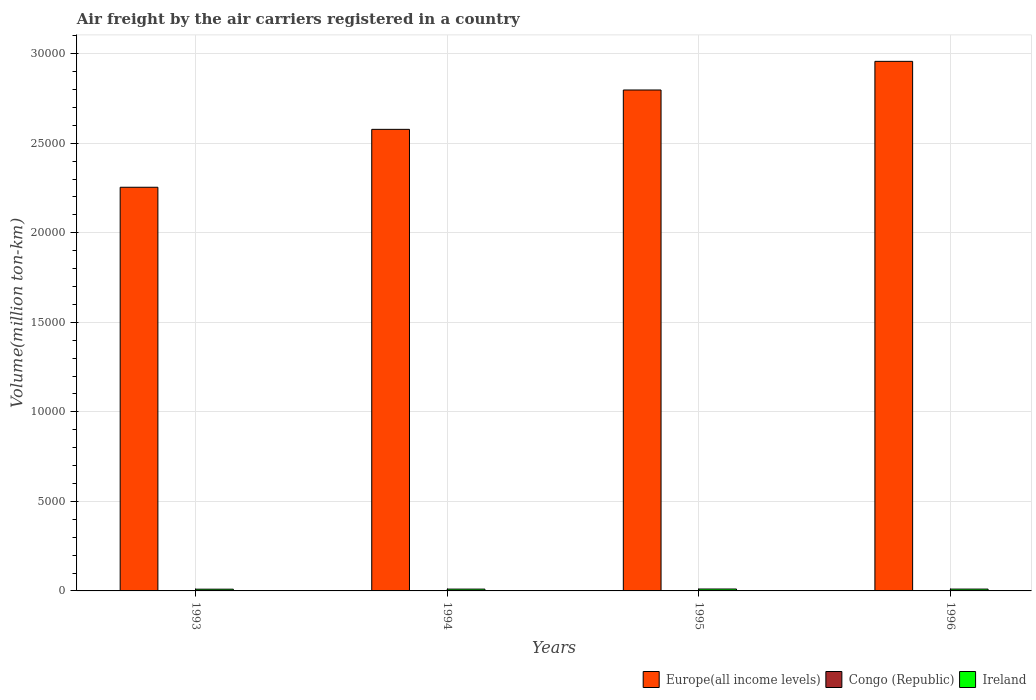How many different coloured bars are there?
Give a very brief answer. 3. Are the number of bars per tick equal to the number of legend labels?
Your answer should be compact. Yes. Are the number of bars on each tick of the X-axis equal?
Your answer should be very brief. Yes. How many bars are there on the 4th tick from the left?
Provide a succinct answer. 3. How many bars are there on the 4th tick from the right?
Your answer should be very brief. 3. Across all years, what is the maximum volume of the air carriers in Europe(all income levels)?
Give a very brief answer. 2.96e+04. Across all years, what is the minimum volume of the air carriers in Europe(all income levels)?
Your answer should be very brief. 2.25e+04. In which year was the volume of the air carriers in Congo (Republic) maximum?
Your answer should be very brief. 1996. What is the total volume of the air carriers in Congo (Republic) in the graph?
Keep it short and to the point. 63.2. What is the difference between the volume of the air carriers in Europe(all income levels) in 1993 and that in 1996?
Provide a succinct answer. -7031.5. What is the difference between the volume of the air carriers in Ireland in 1993 and the volume of the air carriers in Congo (Republic) in 1994?
Provide a succinct answer. 82.3. What is the average volume of the air carriers in Congo (Republic) per year?
Your answer should be very brief. 15.8. In the year 1995, what is the difference between the volume of the air carriers in Congo (Republic) and volume of the air carriers in Ireland?
Provide a short and direct response. -91. What is the ratio of the volume of the air carriers in Congo (Republic) in 1994 to that in 1995?
Offer a terse response. 0.94. What is the difference between the highest and the second highest volume of the air carriers in Ireland?
Offer a terse response. 4.9. What is the difference between the highest and the lowest volume of the air carriers in Congo (Republic)?
Your response must be concise. 2.3. In how many years, is the volume of the air carriers in Ireland greater than the average volume of the air carriers in Ireland taken over all years?
Provide a succinct answer. 2. Is the sum of the volume of the air carriers in Europe(all income levels) in 1993 and 1994 greater than the maximum volume of the air carriers in Ireland across all years?
Keep it short and to the point. Yes. What does the 1st bar from the left in 1996 represents?
Keep it short and to the point. Europe(all income levels). What does the 3rd bar from the right in 1994 represents?
Offer a terse response. Europe(all income levels). What is the difference between two consecutive major ticks on the Y-axis?
Provide a short and direct response. 5000. Where does the legend appear in the graph?
Give a very brief answer. Bottom right. How many legend labels are there?
Provide a succinct answer. 3. What is the title of the graph?
Keep it short and to the point. Air freight by the air carriers registered in a country. Does "Afghanistan" appear as one of the legend labels in the graph?
Your answer should be compact. No. What is the label or title of the X-axis?
Keep it short and to the point. Years. What is the label or title of the Y-axis?
Provide a succinct answer. Volume(million ton-km). What is the Volume(million ton-km) in Europe(all income levels) in 1993?
Your answer should be very brief. 2.25e+04. What is the Volume(million ton-km) of Congo (Republic) in 1993?
Give a very brief answer. 14.9. What is the Volume(million ton-km) in Ireland in 1993?
Your answer should be very brief. 97.4. What is the Volume(million ton-km) in Europe(all income levels) in 1994?
Offer a very short reply. 2.58e+04. What is the Volume(million ton-km) in Congo (Republic) in 1994?
Make the answer very short. 15.1. What is the Volume(million ton-km) in Ireland in 1994?
Provide a succinct answer. 101.2. What is the Volume(million ton-km) of Europe(all income levels) in 1995?
Make the answer very short. 2.80e+04. What is the Volume(million ton-km) of Congo (Republic) in 1995?
Your answer should be compact. 16. What is the Volume(million ton-km) in Ireland in 1995?
Ensure brevity in your answer.  107. What is the Volume(million ton-km) in Europe(all income levels) in 1996?
Give a very brief answer. 2.96e+04. What is the Volume(million ton-km) of Congo (Republic) in 1996?
Your answer should be compact. 17.2. What is the Volume(million ton-km) of Ireland in 1996?
Make the answer very short. 102.1. Across all years, what is the maximum Volume(million ton-km) in Europe(all income levels)?
Provide a succinct answer. 2.96e+04. Across all years, what is the maximum Volume(million ton-km) of Congo (Republic)?
Your response must be concise. 17.2. Across all years, what is the maximum Volume(million ton-km) in Ireland?
Give a very brief answer. 107. Across all years, what is the minimum Volume(million ton-km) in Europe(all income levels)?
Provide a short and direct response. 2.25e+04. Across all years, what is the minimum Volume(million ton-km) of Congo (Republic)?
Offer a very short reply. 14.9. Across all years, what is the minimum Volume(million ton-km) in Ireland?
Give a very brief answer. 97.4. What is the total Volume(million ton-km) in Europe(all income levels) in the graph?
Keep it short and to the point. 1.06e+05. What is the total Volume(million ton-km) of Congo (Republic) in the graph?
Provide a short and direct response. 63.2. What is the total Volume(million ton-km) in Ireland in the graph?
Keep it short and to the point. 407.7. What is the difference between the Volume(million ton-km) of Europe(all income levels) in 1993 and that in 1994?
Offer a very short reply. -3233.8. What is the difference between the Volume(million ton-km) of Ireland in 1993 and that in 1994?
Keep it short and to the point. -3.8. What is the difference between the Volume(million ton-km) in Europe(all income levels) in 1993 and that in 1995?
Keep it short and to the point. -5432.3. What is the difference between the Volume(million ton-km) in Ireland in 1993 and that in 1995?
Your answer should be very brief. -9.6. What is the difference between the Volume(million ton-km) in Europe(all income levels) in 1993 and that in 1996?
Keep it short and to the point. -7031.5. What is the difference between the Volume(million ton-km) of Congo (Republic) in 1993 and that in 1996?
Ensure brevity in your answer.  -2.3. What is the difference between the Volume(million ton-km) in Ireland in 1993 and that in 1996?
Your answer should be compact. -4.7. What is the difference between the Volume(million ton-km) in Europe(all income levels) in 1994 and that in 1995?
Make the answer very short. -2198.5. What is the difference between the Volume(million ton-km) in Congo (Republic) in 1994 and that in 1995?
Provide a succinct answer. -0.9. What is the difference between the Volume(million ton-km) in Europe(all income levels) in 1994 and that in 1996?
Offer a terse response. -3797.7. What is the difference between the Volume(million ton-km) of Ireland in 1994 and that in 1996?
Offer a very short reply. -0.9. What is the difference between the Volume(million ton-km) of Europe(all income levels) in 1995 and that in 1996?
Provide a succinct answer. -1599.2. What is the difference between the Volume(million ton-km) of Congo (Republic) in 1995 and that in 1996?
Keep it short and to the point. -1.2. What is the difference between the Volume(million ton-km) in Ireland in 1995 and that in 1996?
Your response must be concise. 4.9. What is the difference between the Volume(million ton-km) of Europe(all income levels) in 1993 and the Volume(million ton-km) of Congo (Republic) in 1994?
Provide a succinct answer. 2.25e+04. What is the difference between the Volume(million ton-km) of Europe(all income levels) in 1993 and the Volume(million ton-km) of Ireland in 1994?
Your answer should be compact. 2.24e+04. What is the difference between the Volume(million ton-km) of Congo (Republic) in 1993 and the Volume(million ton-km) of Ireland in 1994?
Your answer should be compact. -86.3. What is the difference between the Volume(million ton-km) of Europe(all income levels) in 1993 and the Volume(million ton-km) of Congo (Republic) in 1995?
Your answer should be compact. 2.25e+04. What is the difference between the Volume(million ton-km) in Europe(all income levels) in 1993 and the Volume(million ton-km) in Ireland in 1995?
Ensure brevity in your answer.  2.24e+04. What is the difference between the Volume(million ton-km) in Congo (Republic) in 1993 and the Volume(million ton-km) in Ireland in 1995?
Make the answer very short. -92.1. What is the difference between the Volume(million ton-km) in Europe(all income levels) in 1993 and the Volume(million ton-km) in Congo (Republic) in 1996?
Give a very brief answer. 2.25e+04. What is the difference between the Volume(million ton-km) of Europe(all income levels) in 1993 and the Volume(million ton-km) of Ireland in 1996?
Your answer should be compact. 2.24e+04. What is the difference between the Volume(million ton-km) in Congo (Republic) in 1993 and the Volume(million ton-km) in Ireland in 1996?
Give a very brief answer. -87.2. What is the difference between the Volume(million ton-km) in Europe(all income levels) in 1994 and the Volume(million ton-km) in Congo (Republic) in 1995?
Your answer should be compact. 2.58e+04. What is the difference between the Volume(million ton-km) in Europe(all income levels) in 1994 and the Volume(million ton-km) in Ireland in 1995?
Provide a short and direct response. 2.57e+04. What is the difference between the Volume(million ton-km) of Congo (Republic) in 1994 and the Volume(million ton-km) of Ireland in 1995?
Make the answer very short. -91.9. What is the difference between the Volume(million ton-km) in Europe(all income levels) in 1994 and the Volume(million ton-km) in Congo (Republic) in 1996?
Keep it short and to the point. 2.58e+04. What is the difference between the Volume(million ton-km) in Europe(all income levels) in 1994 and the Volume(million ton-km) in Ireland in 1996?
Ensure brevity in your answer.  2.57e+04. What is the difference between the Volume(million ton-km) in Congo (Republic) in 1994 and the Volume(million ton-km) in Ireland in 1996?
Provide a short and direct response. -87. What is the difference between the Volume(million ton-km) in Europe(all income levels) in 1995 and the Volume(million ton-km) in Congo (Republic) in 1996?
Keep it short and to the point. 2.80e+04. What is the difference between the Volume(million ton-km) of Europe(all income levels) in 1995 and the Volume(million ton-km) of Ireland in 1996?
Make the answer very short. 2.79e+04. What is the difference between the Volume(million ton-km) in Congo (Republic) in 1995 and the Volume(million ton-km) in Ireland in 1996?
Offer a terse response. -86.1. What is the average Volume(million ton-km) in Europe(all income levels) per year?
Offer a very short reply. 2.65e+04. What is the average Volume(million ton-km) of Ireland per year?
Provide a short and direct response. 101.92. In the year 1993, what is the difference between the Volume(million ton-km) in Europe(all income levels) and Volume(million ton-km) in Congo (Republic)?
Your response must be concise. 2.25e+04. In the year 1993, what is the difference between the Volume(million ton-km) in Europe(all income levels) and Volume(million ton-km) in Ireland?
Provide a short and direct response. 2.24e+04. In the year 1993, what is the difference between the Volume(million ton-km) of Congo (Republic) and Volume(million ton-km) of Ireland?
Make the answer very short. -82.5. In the year 1994, what is the difference between the Volume(million ton-km) of Europe(all income levels) and Volume(million ton-km) of Congo (Republic)?
Ensure brevity in your answer.  2.58e+04. In the year 1994, what is the difference between the Volume(million ton-km) of Europe(all income levels) and Volume(million ton-km) of Ireland?
Your answer should be very brief. 2.57e+04. In the year 1994, what is the difference between the Volume(million ton-km) of Congo (Republic) and Volume(million ton-km) of Ireland?
Give a very brief answer. -86.1. In the year 1995, what is the difference between the Volume(million ton-km) of Europe(all income levels) and Volume(million ton-km) of Congo (Republic)?
Ensure brevity in your answer.  2.80e+04. In the year 1995, what is the difference between the Volume(million ton-km) of Europe(all income levels) and Volume(million ton-km) of Ireland?
Make the answer very short. 2.79e+04. In the year 1995, what is the difference between the Volume(million ton-km) in Congo (Republic) and Volume(million ton-km) in Ireland?
Give a very brief answer. -91. In the year 1996, what is the difference between the Volume(million ton-km) of Europe(all income levels) and Volume(million ton-km) of Congo (Republic)?
Give a very brief answer. 2.96e+04. In the year 1996, what is the difference between the Volume(million ton-km) of Europe(all income levels) and Volume(million ton-km) of Ireland?
Make the answer very short. 2.95e+04. In the year 1996, what is the difference between the Volume(million ton-km) in Congo (Republic) and Volume(million ton-km) in Ireland?
Make the answer very short. -84.9. What is the ratio of the Volume(million ton-km) of Europe(all income levels) in 1993 to that in 1994?
Ensure brevity in your answer.  0.87. What is the ratio of the Volume(million ton-km) in Ireland in 1993 to that in 1994?
Your response must be concise. 0.96. What is the ratio of the Volume(million ton-km) in Europe(all income levels) in 1993 to that in 1995?
Provide a short and direct response. 0.81. What is the ratio of the Volume(million ton-km) in Congo (Republic) in 1993 to that in 1995?
Offer a terse response. 0.93. What is the ratio of the Volume(million ton-km) of Ireland in 1993 to that in 1995?
Your answer should be compact. 0.91. What is the ratio of the Volume(million ton-km) in Europe(all income levels) in 1993 to that in 1996?
Your answer should be very brief. 0.76. What is the ratio of the Volume(million ton-km) in Congo (Republic) in 1993 to that in 1996?
Give a very brief answer. 0.87. What is the ratio of the Volume(million ton-km) of Ireland in 1993 to that in 1996?
Offer a terse response. 0.95. What is the ratio of the Volume(million ton-km) in Europe(all income levels) in 1994 to that in 1995?
Offer a very short reply. 0.92. What is the ratio of the Volume(million ton-km) of Congo (Republic) in 1994 to that in 1995?
Provide a short and direct response. 0.94. What is the ratio of the Volume(million ton-km) in Ireland in 1994 to that in 1995?
Your answer should be very brief. 0.95. What is the ratio of the Volume(million ton-km) of Europe(all income levels) in 1994 to that in 1996?
Offer a terse response. 0.87. What is the ratio of the Volume(million ton-km) of Congo (Republic) in 1994 to that in 1996?
Offer a very short reply. 0.88. What is the ratio of the Volume(million ton-km) in Ireland in 1994 to that in 1996?
Ensure brevity in your answer.  0.99. What is the ratio of the Volume(million ton-km) of Europe(all income levels) in 1995 to that in 1996?
Your answer should be compact. 0.95. What is the ratio of the Volume(million ton-km) of Congo (Republic) in 1995 to that in 1996?
Provide a succinct answer. 0.93. What is the ratio of the Volume(million ton-km) of Ireland in 1995 to that in 1996?
Provide a succinct answer. 1.05. What is the difference between the highest and the second highest Volume(million ton-km) of Europe(all income levels)?
Your response must be concise. 1599.2. What is the difference between the highest and the second highest Volume(million ton-km) in Congo (Republic)?
Your answer should be compact. 1.2. What is the difference between the highest and the lowest Volume(million ton-km) of Europe(all income levels)?
Offer a terse response. 7031.5. What is the difference between the highest and the lowest Volume(million ton-km) of Ireland?
Provide a short and direct response. 9.6. 